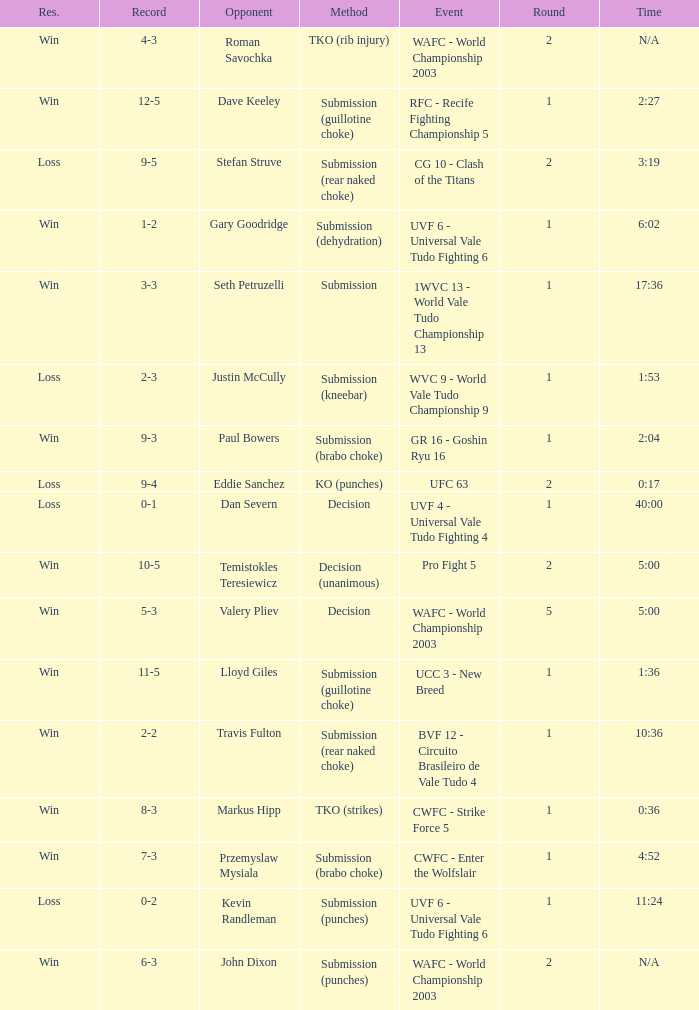What round has the highest Res loss, and a time of 40:00? 1.0. 